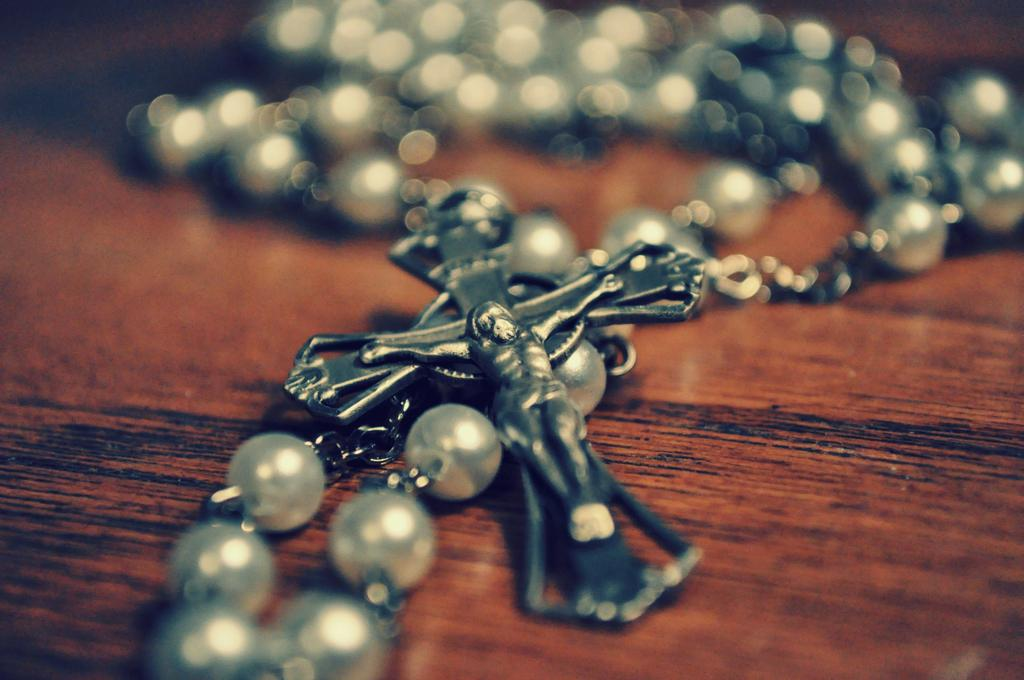What religious symbol is present in the image? There is a Jesus cross in the image. What other item can be seen in the image related to religious practices? There is a rosary bead necklace in the image. On what surface is the rosary bead necklace placed? The rosary bead necklace is on a wooden surface. What type of development can be seen in the image? There is no development or construction project visible in the image; it features a Jesus cross and a rosary bead necklace on a wooden surface. What journey is depicted in the image? There is no journey or travel depicted in the image; it focuses on religious symbols and items. 